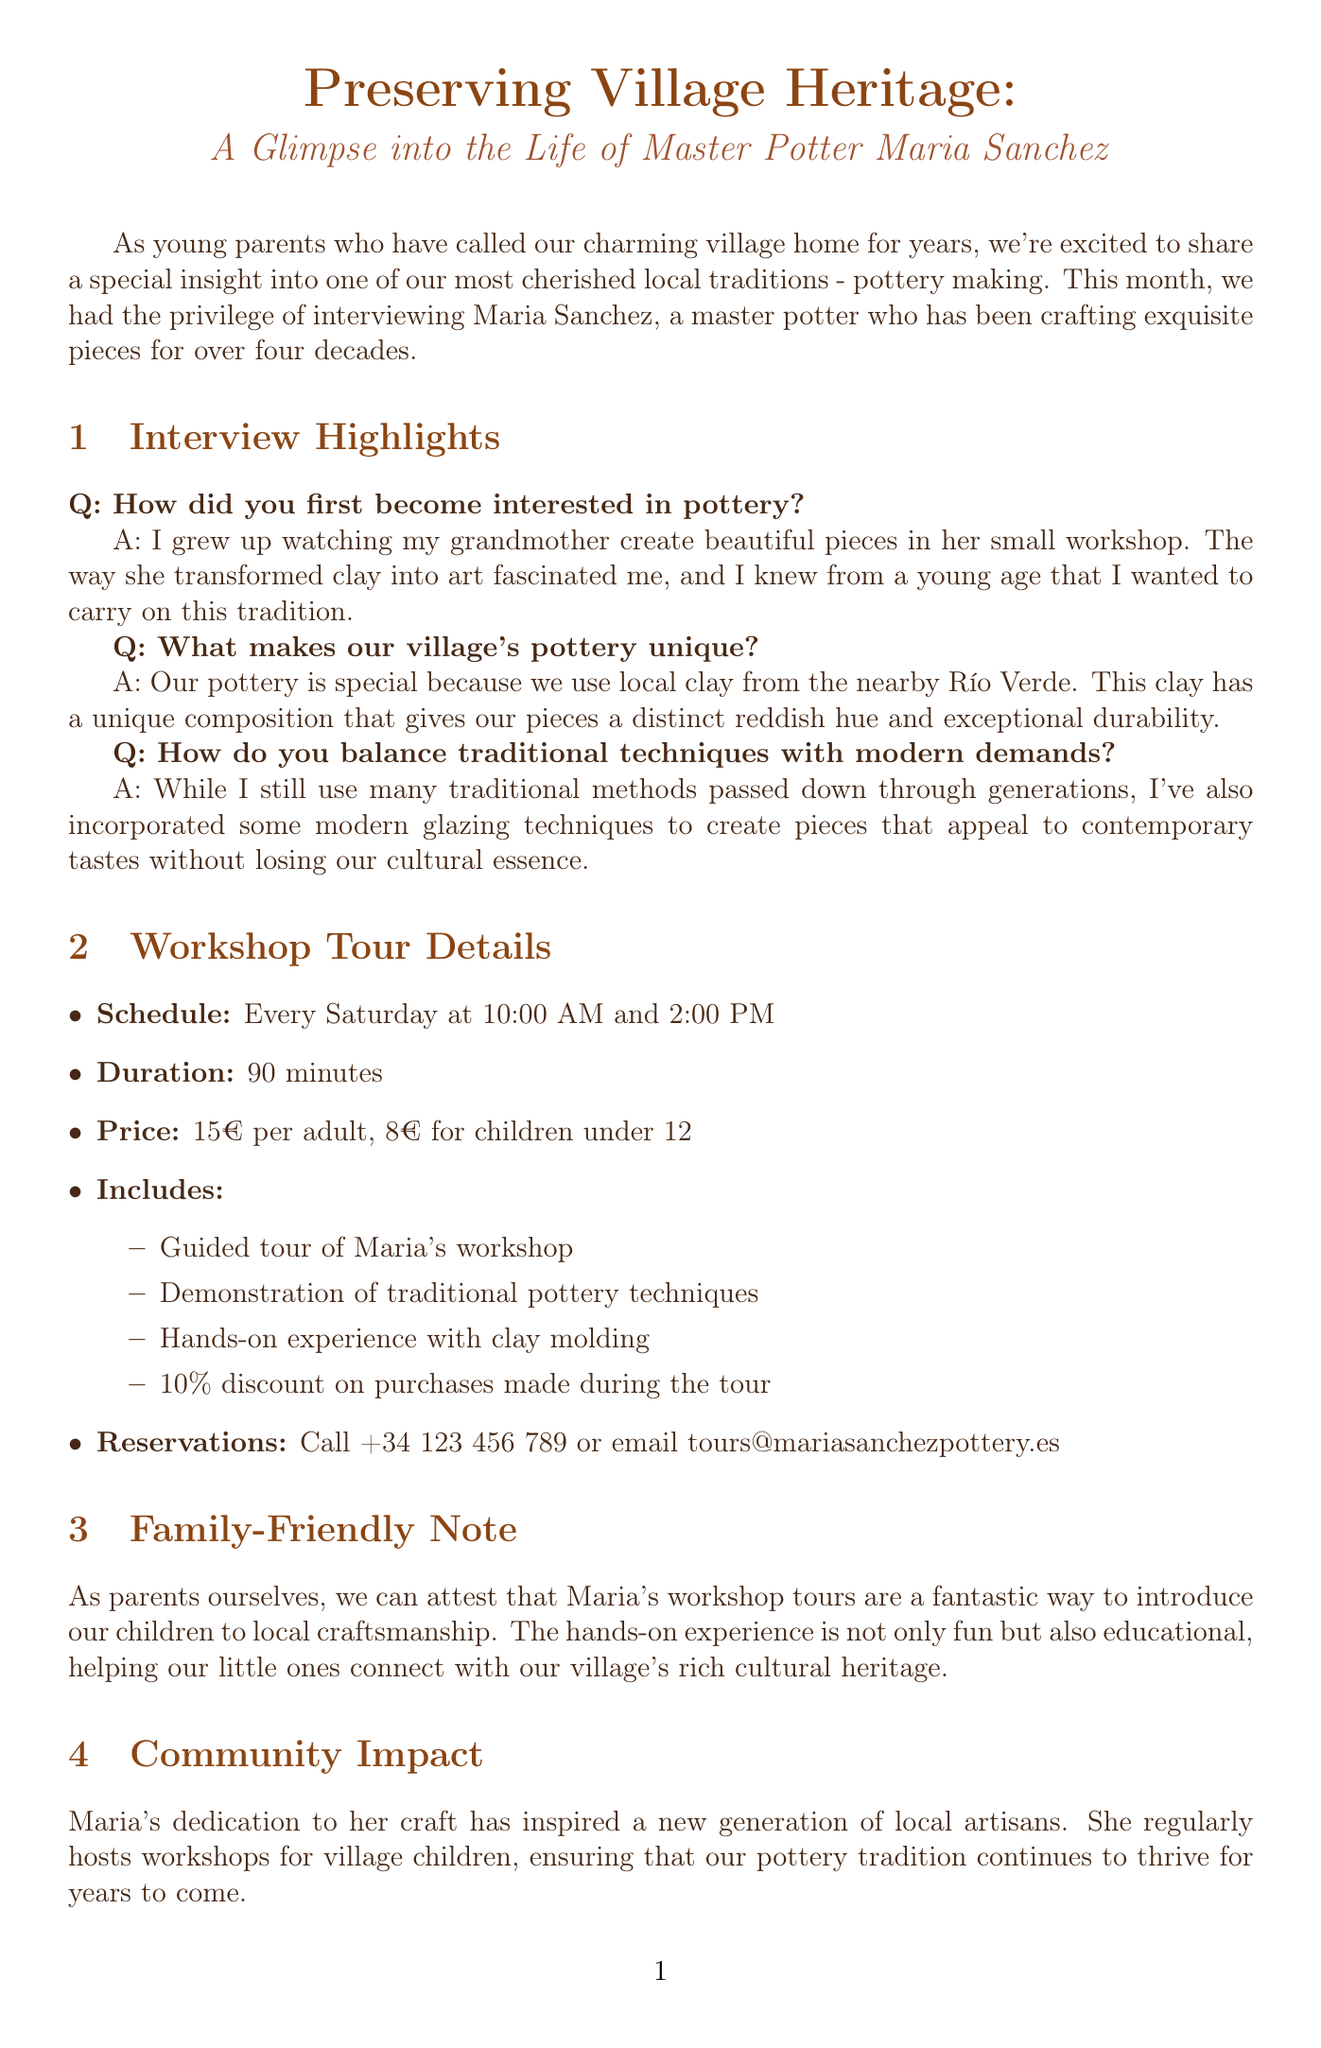What is the name of the master potter featured? The document introduces Maria Sanchez as the master potter being highlighted in the newsletter.
Answer: Maria Sanchez How long has Maria been crafting pottery? The newsletter states that Maria has been crafting exquisite pieces for over four decades.
Answer: Over four decades What is the price for children under 12 for the workshop tour? The document specifies the price for children under 12 attending the workshop tour.
Answer: 8€ What unique material is used for the village's pottery? The answer is found in Maria's explanation about the clay used for pottery, which comes from a specific local source.
Answer: Local clay from the nearby Río Verde How often are the workshop tours held? The frequency of the workshop tours is mentioned in the scheduling section of the document.
Answer: Every Saturday What is included in the workshop tour? The document lists specific experiences that are part of the workshop tour offered by Maria.
Answer: Guided tour of Maria's workshop, demonstration, hands-on experience, discount What impact has Maria had on the local community? The document discusses Maria's influence, specifically on local artisans and children in the village.
Answer: Inspired a new generation of local artisans What are the opening hours for Maria's pottery studio? The document provides specific weekday and time details for when the pottery studio is open.
Answer: Tuesday to Saturday, 9:00 AM - 6:00 PM What type of event does the Village Artisan Market hold? The document mentions the type and frequency of events held at the Village Artisan Market.
Answer: Monthly market event 